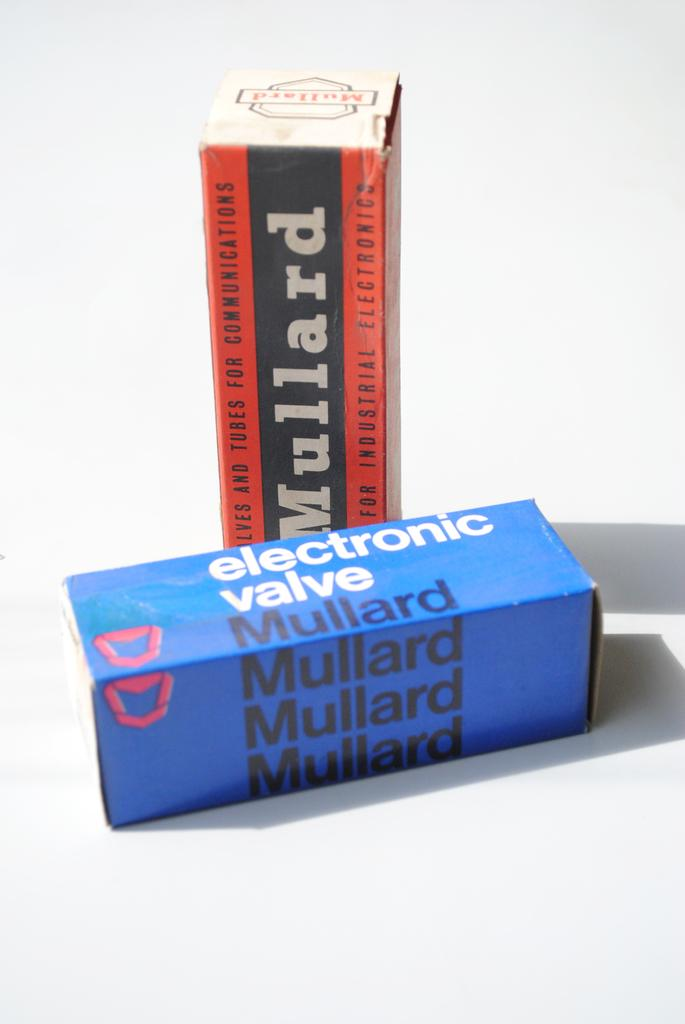<image>
Write a terse but informative summary of the picture. new boxes of electronic valve and mullard box 